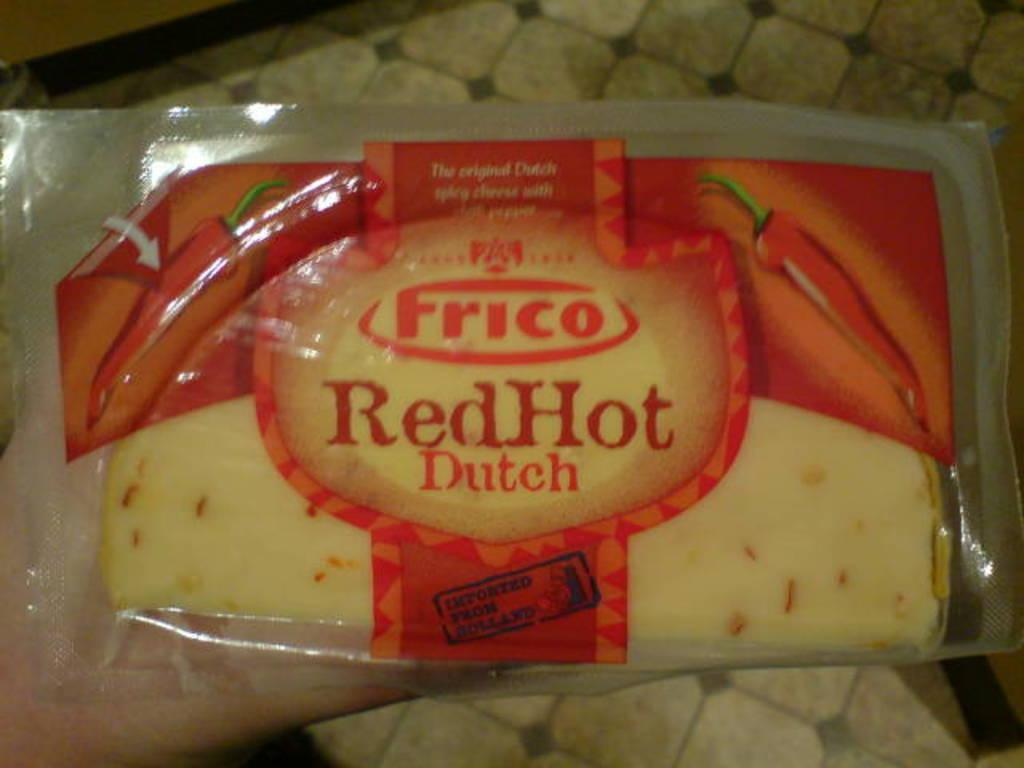Who or what is the main subject in the image? There is a person in the image. What is the person holding in the image? The person is holding a food product. Can you describe the packaging of the food product? The food product is in a red and transparent plastic packet. How many geese are flying in a circle around the person in the image? There are no geese present in the image. What type of pail is being used by the person to hold the food product? The person is not using a pail to hold the food product; it is in a red and transparent plastic packet. 